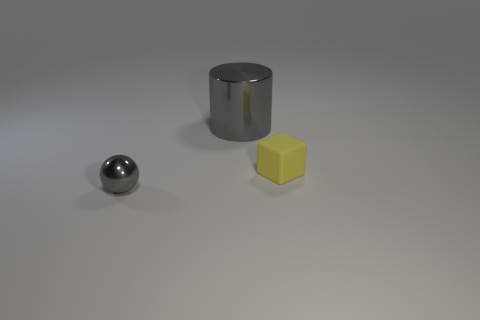Add 2 tiny gray balls. How many objects exist? 5 Subtract all cylinders. How many objects are left? 2 Add 2 gray shiny cylinders. How many gray shiny cylinders are left? 3 Add 3 big yellow metal cylinders. How many big yellow metal cylinders exist? 3 Subtract 0 purple balls. How many objects are left? 3 Subtract all brown metal spheres. Subtract all gray balls. How many objects are left? 2 